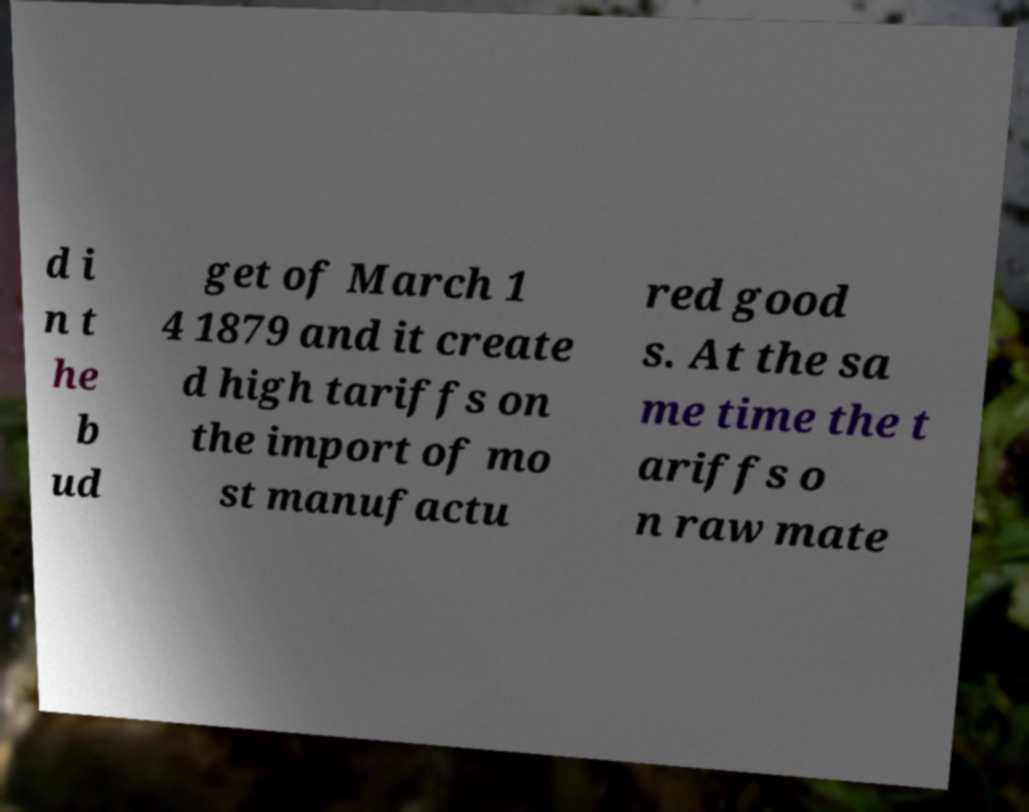Can you read and provide the text displayed in the image?This photo seems to have some interesting text. Can you extract and type it out for me? d i n t he b ud get of March 1 4 1879 and it create d high tariffs on the import of mo st manufactu red good s. At the sa me time the t ariffs o n raw mate 